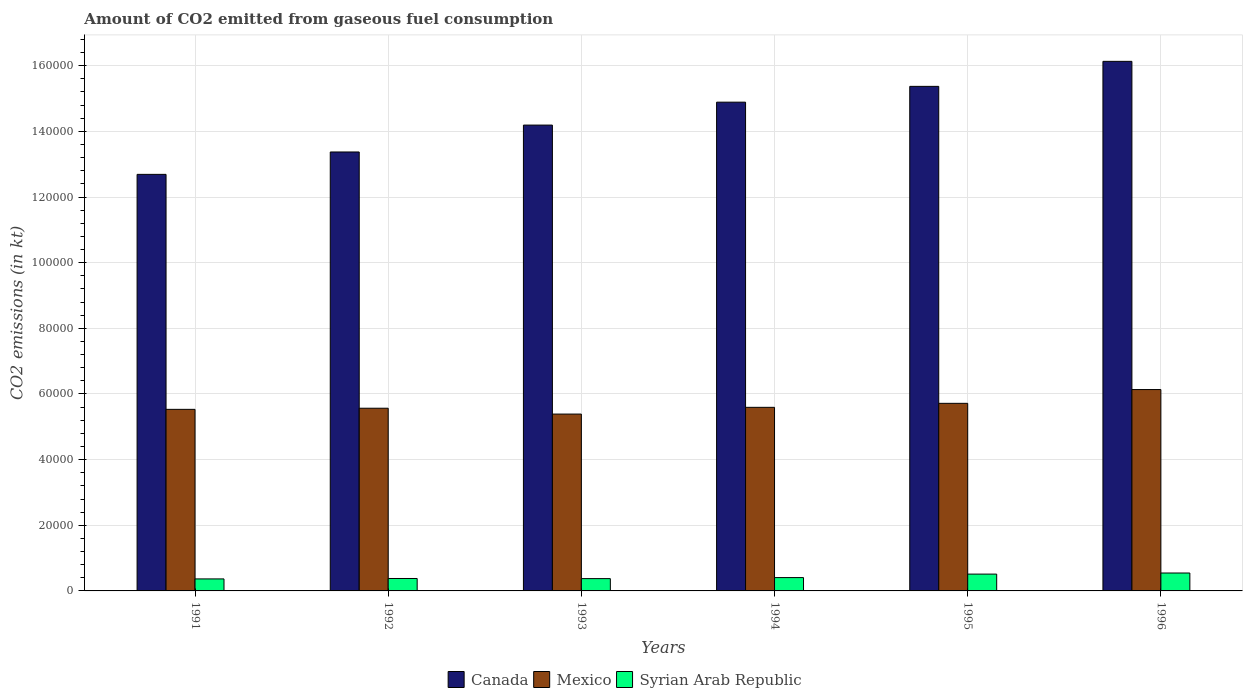Are the number of bars per tick equal to the number of legend labels?
Make the answer very short. Yes. Are the number of bars on each tick of the X-axis equal?
Keep it short and to the point. Yes. How many bars are there on the 5th tick from the right?
Your answer should be compact. 3. What is the label of the 3rd group of bars from the left?
Make the answer very short. 1993. What is the amount of CO2 emitted in Canada in 1994?
Offer a terse response. 1.49e+05. Across all years, what is the maximum amount of CO2 emitted in Syrian Arab Republic?
Offer a very short reply. 5456.5. Across all years, what is the minimum amount of CO2 emitted in Canada?
Keep it short and to the point. 1.27e+05. In which year was the amount of CO2 emitted in Canada maximum?
Keep it short and to the point. 1996. In which year was the amount of CO2 emitted in Mexico minimum?
Your response must be concise. 1993. What is the total amount of CO2 emitted in Mexico in the graph?
Offer a terse response. 3.39e+05. What is the difference between the amount of CO2 emitted in Canada in 1994 and that in 1995?
Keep it short and to the point. -4814.77. What is the difference between the amount of CO2 emitted in Canada in 1992 and the amount of CO2 emitted in Syrian Arab Republic in 1991?
Provide a succinct answer. 1.30e+05. What is the average amount of CO2 emitted in Syrian Arab Republic per year?
Keep it short and to the point. 4305.67. In the year 1995, what is the difference between the amount of CO2 emitted in Mexico and amount of CO2 emitted in Canada?
Your answer should be very brief. -9.66e+04. What is the ratio of the amount of CO2 emitted in Canada in 1995 to that in 1996?
Keep it short and to the point. 0.95. What is the difference between the highest and the second highest amount of CO2 emitted in Mexico?
Ensure brevity in your answer.  4198.72. What is the difference between the highest and the lowest amount of CO2 emitted in Syrian Arab Republic?
Offer a very short reply. 1796.83. What does the 3rd bar from the left in 1993 represents?
Give a very brief answer. Syrian Arab Republic. How many bars are there?
Keep it short and to the point. 18. Are all the bars in the graph horizontal?
Offer a very short reply. No. What is the difference between two consecutive major ticks on the Y-axis?
Offer a very short reply. 2.00e+04. Does the graph contain any zero values?
Provide a succinct answer. No. What is the title of the graph?
Your answer should be compact. Amount of CO2 emitted from gaseous fuel consumption. Does "South Africa" appear as one of the legend labels in the graph?
Your answer should be compact. No. What is the label or title of the Y-axis?
Ensure brevity in your answer.  CO2 emissions (in kt). What is the CO2 emissions (in kt) of Canada in 1991?
Make the answer very short. 1.27e+05. What is the CO2 emissions (in kt) in Mexico in 1991?
Offer a terse response. 5.53e+04. What is the CO2 emissions (in kt) in Syrian Arab Republic in 1991?
Keep it short and to the point. 3659.67. What is the CO2 emissions (in kt) in Canada in 1992?
Ensure brevity in your answer.  1.34e+05. What is the CO2 emissions (in kt) in Mexico in 1992?
Offer a very short reply. 5.57e+04. What is the CO2 emissions (in kt) in Syrian Arab Republic in 1992?
Offer a terse response. 3784.34. What is the CO2 emissions (in kt) in Canada in 1993?
Provide a short and direct response. 1.42e+05. What is the CO2 emissions (in kt) of Mexico in 1993?
Make the answer very short. 5.39e+04. What is the CO2 emissions (in kt) of Syrian Arab Republic in 1993?
Provide a short and direct response. 3747.67. What is the CO2 emissions (in kt) in Canada in 1994?
Offer a very short reply. 1.49e+05. What is the CO2 emissions (in kt) in Mexico in 1994?
Provide a short and direct response. 5.59e+04. What is the CO2 emissions (in kt) in Syrian Arab Republic in 1994?
Offer a very short reply. 4063.04. What is the CO2 emissions (in kt) in Canada in 1995?
Your answer should be very brief. 1.54e+05. What is the CO2 emissions (in kt) in Mexico in 1995?
Offer a very short reply. 5.71e+04. What is the CO2 emissions (in kt) of Syrian Arab Republic in 1995?
Your response must be concise. 5122.8. What is the CO2 emissions (in kt) in Canada in 1996?
Provide a succinct answer. 1.61e+05. What is the CO2 emissions (in kt) of Mexico in 1996?
Keep it short and to the point. 6.13e+04. What is the CO2 emissions (in kt) of Syrian Arab Republic in 1996?
Give a very brief answer. 5456.5. Across all years, what is the maximum CO2 emissions (in kt) of Canada?
Offer a terse response. 1.61e+05. Across all years, what is the maximum CO2 emissions (in kt) in Mexico?
Give a very brief answer. 6.13e+04. Across all years, what is the maximum CO2 emissions (in kt) of Syrian Arab Republic?
Keep it short and to the point. 5456.5. Across all years, what is the minimum CO2 emissions (in kt) in Canada?
Make the answer very short. 1.27e+05. Across all years, what is the minimum CO2 emissions (in kt) of Mexico?
Your answer should be compact. 5.39e+04. Across all years, what is the minimum CO2 emissions (in kt) of Syrian Arab Republic?
Provide a succinct answer. 3659.67. What is the total CO2 emissions (in kt) in Canada in the graph?
Your response must be concise. 8.66e+05. What is the total CO2 emissions (in kt) in Mexico in the graph?
Your response must be concise. 3.39e+05. What is the total CO2 emissions (in kt) in Syrian Arab Republic in the graph?
Keep it short and to the point. 2.58e+04. What is the difference between the CO2 emissions (in kt) of Canada in 1991 and that in 1992?
Your answer should be compact. -6820.62. What is the difference between the CO2 emissions (in kt) in Mexico in 1991 and that in 1992?
Offer a very short reply. -344.7. What is the difference between the CO2 emissions (in kt) in Syrian Arab Republic in 1991 and that in 1992?
Your answer should be very brief. -124.68. What is the difference between the CO2 emissions (in kt) in Canada in 1991 and that in 1993?
Offer a very short reply. -1.50e+04. What is the difference between the CO2 emissions (in kt) of Mexico in 1991 and that in 1993?
Keep it short and to the point. 1437.46. What is the difference between the CO2 emissions (in kt) of Syrian Arab Republic in 1991 and that in 1993?
Give a very brief answer. -88.01. What is the difference between the CO2 emissions (in kt) in Canada in 1991 and that in 1994?
Your answer should be compact. -2.20e+04. What is the difference between the CO2 emissions (in kt) in Mexico in 1991 and that in 1994?
Make the answer very short. -616.06. What is the difference between the CO2 emissions (in kt) of Syrian Arab Republic in 1991 and that in 1994?
Keep it short and to the point. -403.37. What is the difference between the CO2 emissions (in kt) of Canada in 1991 and that in 1995?
Offer a terse response. -2.68e+04. What is the difference between the CO2 emissions (in kt) of Mexico in 1991 and that in 1995?
Keep it short and to the point. -1833.5. What is the difference between the CO2 emissions (in kt) of Syrian Arab Republic in 1991 and that in 1995?
Provide a succinct answer. -1463.13. What is the difference between the CO2 emissions (in kt) in Canada in 1991 and that in 1996?
Keep it short and to the point. -3.44e+04. What is the difference between the CO2 emissions (in kt) of Mexico in 1991 and that in 1996?
Keep it short and to the point. -6032.22. What is the difference between the CO2 emissions (in kt) in Syrian Arab Republic in 1991 and that in 1996?
Offer a very short reply. -1796.83. What is the difference between the CO2 emissions (in kt) of Canada in 1992 and that in 1993?
Give a very brief answer. -8195.75. What is the difference between the CO2 emissions (in kt) of Mexico in 1992 and that in 1993?
Offer a terse response. 1782.16. What is the difference between the CO2 emissions (in kt) in Syrian Arab Republic in 1992 and that in 1993?
Make the answer very short. 36.67. What is the difference between the CO2 emissions (in kt) in Canada in 1992 and that in 1994?
Give a very brief answer. -1.52e+04. What is the difference between the CO2 emissions (in kt) of Mexico in 1992 and that in 1994?
Your answer should be compact. -271.36. What is the difference between the CO2 emissions (in kt) in Syrian Arab Republic in 1992 and that in 1994?
Make the answer very short. -278.69. What is the difference between the CO2 emissions (in kt) in Canada in 1992 and that in 1995?
Make the answer very short. -2.00e+04. What is the difference between the CO2 emissions (in kt) of Mexico in 1992 and that in 1995?
Make the answer very short. -1488.8. What is the difference between the CO2 emissions (in kt) of Syrian Arab Republic in 1992 and that in 1995?
Provide a short and direct response. -1338.45. What is the difference between the CO2 emissions (in kt) of Canada in 1992 and that in 1996?
Your answer should be compact. -2.76e+04. What is the difference between the CO2 emissions (in kt) in Mexico in 1992 and that in 1996?
Provide a succinct answer. -5687.52. What is the difference between the CO2 emissions (in kt) of Syrian Arab Republic in 1992 and that in 1996?
Your answer should be very brief. -1672.15. What is the difference between the CO2 emissions (in kt) of Canada in 1993 and that in 1994?
Give a very brief answer. -6978.3. What is the difference between the CO2 emissions (in kt) of Mexico in 1993 and that in 1994?
Your answer should be compact. -2053.52. What is the difference between the CO2 emissions (in kt) of Syrian Arab Republic in 1993 and that in 1994?
Keep it short and to the point. -315.36. What is the difference between the CO2 emissions (in kt) of Canada in 1993 and that in 1995?
Provide a short and direct response. -1.18e+04. What is the difference between the CO2 emissions (in kt) in Mexico in 1993 and that in 1995?
Ensure brevity in your answer.  -3270.96. What is the difference between the CO2 emissions (in kt) of Syrian Arab Republic in 1993 and that in 1995?
Make the answer very short. -1375.12. What is the difference between the CO2 emissions (in kt) of Canada in 1993 and that in 1996?
Your answer should be very brief. -1.94e+04. What is the difference between the CO2 emissions (in kt) of Mexico in 1993 and that in 1996?
Give a very brief answer. -7469.68. What is the difference between the CO2 emissions (in kt) in Syrian Arab Republic in 1993 and that in 1996?
Your answer should be very brief. -1708.82. What is the difference between the CO2 emissions (in kt) of Canada in 1994 and that in 1995?
Offer a terse response. -4814.77. What is the difference between the CO2 emissions (in kt) in Mexico in 1994 and that in 1995?
Make the answer very short. -1217.44. What is the difference between the CO2 emissions (in kt) of Syrian Arab Republic in 1994 and that in 1995?
Your answer should be very brief. -1059.76. What is the difference between the CO2 emissions (in kt) of Canada in 1994 and that in 1996?
Offer a terse response. -1.24e+04. What is the difference between the CO2 emissions (in kt) in Mexico in 1994 and that in 1996?
Your answer should be compact. -5416.16. What is the difference between the CO2 emissions (in kt) of Syrian Arab Republic in 1994 and that in 1996?
Your response must be concise. -1393.46. What is the difference between the CO2 emissions (in kt) in Canada in 1995 and that in 1996?
Ensure brevity in your answer.  -7620.03. What is the difference between the CO2 emissions (in kt) of Mexico in 1995 and that in 1996?
Keep it short and to the point. -4198.72. What is the difference between the CO2 emissions (in kt) of Syrian Arab Republic in 1995 and that in 1996?
Give a very brief answer. -333.7. What is the difference between the CO2 emissions (in kt) in Canada in 1991 and the CO2 emissions (in kt) in Mexico in 1992?
Keep it short and to the point. 7.12e+04. What is the difference between the CO2 emissions (in kt) in Canada in 1991 and the CO2 emissions (in kt) in Syrian Arab Republic in 1992?
Ensure brevity in your answer.  1.23e+05. What is the difference between the CO2 emissions (in kt) in Mexico in 1991 and the CO2 emissions (in kt) in Syrian Arab Republic in 1992?
Ensure brevity in your answer.  5.15e+04. What is the difference between the CO2 emissions (in kt) of Canada in 1991 and the CO2 emissions (in kt) of Mexico in 1993?
Provide a succinct answer. 7.30e+04. What is the difference between the CO2 emissions (in kt) in Canada in 1991 and the CO2 emissions (in kt) in Syrian Arab Republic in 1993?
Make the answer very short. 1.23e+05. What is the difference between the CO2 emissions (in kt) of Mexico in 1991 and the CO2 emissions (in kt) of Syrian Arab Republic in 1993?
Your response must be concise. 5.16e+04. What is the difference between the CO2 emissions (in kt) of Canada in 1991 and the CO2 emissions (in kt) of Mexico in 1994?
Give a very brief answer. 7.10e+04. What is the difference between the CO2 emissions (in kt) of Canada in 1991 and the CO2 emissions (in kt) of Syrian Arab Republic in 1994?
Your answer should be compact. 1.23e+05. What is the difference between the CO2 emissions (in kt) in Mexico in 1991 and the CO2 emissions (in kt) in Syrian Arab Republic in 1994?
Give a very brief answer. 5.12e+04. What is the difference between the CO2 emissions (in kt) in Canada in 1991 and the CO2 emissions (in kt) in Mexico in 1995?
Ensure brevity in your answer.  6.98e+04. What is the difference between the CO2 emissions (in kt) in Canada in 1991 and the CO2 emissions (in kt) in Syrian Arab Republic in 1995?
Offer a very short reply. 1.22e+05. What is the difference between the CO2 emissions (in kt) of Mexico in 1991 and the CO2 emissions (in kt) of Syrian Arab Republic in 1995?
Provide a succinct answer. 5.02e+04. What is the difference between the CO2 emissions (in kt) in Canada in 1991 and the CO2 emissions (in kt) in Mexico in 1996?
Your response must be concise. 6.56e+04. What is the difference between the CO2 emissions (in kt) in Canada in 1991 and the CO2 emissions (in kt) in Syrian Arab Republic in 1996?
Provide a short and direct response. 1.21e+05. What is the difference between the CO2 emissions (in kt) of Mexico in 1991 and the CO2 emissions (in kt) of Syrian Arab Republic in 1996?
Offer a terse response. 4.99e+04. What is the difference between the CO2 emissions (in kt) in Canada in 1992 and the CO2 emissions (in kt) in Mexico in 1993?
Offer a very short reply. 7.98e+04. What is the difference between the CO2 emissions (in kt) in Canada in 1992 and the CO2 emissions (in kt) in Syrian Arab Republic in 1993?
Offer a very short reply. 1.30e+05. What is the difference between the CO2 emissions (in kt) of Mexico in 1992 and the CO2 emissions (in kt) of Syrian Arab Republic in 1993?
Offer a terse response. 5.19e+04. What is the difference between the CO2 emissions (in kt) of Canada in 1992 and the CO2 emissions (in kt) of Mexico in 1994?
Ensure brevity in your answer.  7.78e+04. What is the difference between the CO2 emissions (in kt) of Canada in 1992 and the CO2 emissions (in kt) of Syrian Arab Republic in 1994?
Your response must be concise. 1.30e+05. What is the difference between the CO2 emissions (in kt) of Mexico in 1992 and the CO2 emissions (in kt) of Syrian Arab Republic in 1994?
Ensure brevity in your answer.  5.16e+04. What is the difference between the CO2 emissions (in kt) of Canada in 1992 and the CO2 emissions (in kt) of Mexico in 1995?
Your response must be concise. 7.66e+04. What is the difference between the CO2 emissions (in kt) of Canada in 1992 and the CO2 emissions (in kt) of Syrian Arab Republic in 1995?
Your response must be concise. 1.29e+05. What is the difference between the CO2 emissions (in kt) in Mexico in 1992 and the CO2 emissions (in kt) in Syrian Arab Republic in 1995?
Your answer should be compact. 5.05e+04. What is the difference between the CO2 emissions (in kt) in Canada in 1992 and the CO2 emissions (in kt) in Mexico in 1996?
Offer a very short reply. 7.24e+04. What is the difference between the CO2 emissions (in kt) in Canada in 1992 and the CO2 emissions (in kt) in Syrian Arab Republic in 1996?
Give a very brief answer. 1.28e+05. What is the difference between the CO2 emissions (in kt) of Mexico in 1992 and the CO2 emissions (in kt) of Syrian Arab Republic in 1996?
Provide a succinct answer. 5.02e+04. What is the difference between the CO2 emissions (in kt) in Canada in 1993 and the CO2 emissions (in kt) in Mexico in 1994?
Offer a very short reply. 8.60e+04. What is the difference between the CO2 emissions (in kt) in Canada in 1993 and the CO2 emissions (in kt) in Syrian Arab Republic in 1994?
Give a very brief answer. 1.38e+05. What is the difference between the CO2 emissions (in kt) in Mexico in 1993 and the CO2 emissions (in kt) in Syrian Arab Republic in 1994?
Provide a succinct answer. 4.98e+04. What is the difference between the CO2 emissions (in kt) of Canada in 1993 and the CO2 emissions (in kt) of Mexico in 1995?
Your answer should be compact. 8.48e+04. What is the difference between the CO2 emissions (in kt) of Canada in 1993 and the CO2 emissions (in kt) of Syrian Arab Republic in 1995?
Offer a very short reply. 1.37e+05. What is the difference between the CO2 emissions (in kt) in Mexico in 1993 and the CO2 emissions (in kt) in Syrian Arab Republic in 1995?
Your answer should be very brief. 4.88e+04. What is the difference between the CO2 emissions (in kt) of Canada in 1993 and the CO2 emissions (in kt) of Mexico in 1996?
Your answer should be very brief. 8.06e+04. What is the difference between the CO2 emissions (in kt) of Canada in 1993 and the CO2 emissions (in kt) of Syrian Arab Republic in 1996?
Offer a terse response. 1.36e+05. What is the difference between the CO2 emissions (in kt) in Mexico in 1993 and the CO2 emissions (in kt) in Syrian Arab Republic in 1996?
Offer a very short reply. 4.84e+04. What is the difference between the CO2 emissions (in kt) of Canada in 1994 and the CO2 emissions (in kt) of Mexico in 1995?
Your answer should be very brief. 9.17e+04. What is the difference between the CO2 emissions (in kt) of Canada in 1994 and the CO2 emissions (in kt) of Syrian Arab Republic in 1995?
Your answer should be compact. 1.44e+05. What is the difference between the CO2 emissions (in kt) of Mexico in 1994 and the CO2 emissions (in kt) of Syrian Arab Republic in 1995?
Keep it short and to the point. 5.08e+04. What is the difference between the CO2 emissions (in kt) of Canada in 1994 and the CO2 emissions (in kt) of Mexico in 1996?
Give a very brief answer. 8.75e+04. What is the difference between the CO2 emissions (in kt) in Canada in 1994 and the CO2 emissions (in kt) in Syrian Arab Republic in 1996?
Your answer should be very brief. 1.43e+05. What is the difference between the CO2 emissions (in kt) in Mexico in 1994 and the CO2 emissions (in kt) in Syrian Arab Republic in 1996?
Make the answer very short. 5.05e+04. What is the difference between the CO2 emissions (in kt) of Canada in 1995 and the CO2 emissions (in kt) of Mexico in 1996?
Provide a succinct answer. 9.24e+04. What is the difference between the CO2 emissions (in kt) of Canada in 1995 and the CO2 emissions (in kt) of Syrian Arab Republic in 1996?
Offer a very short reply. 1.48e+05. What is the difference between the CO2 emissions (in kt) of Mexico in 1995 and the CO2 emissions (in kt) of Syrian Arab Republic in 1996?
Make the answer very short. 5.17e+04. What is the average CO2 emissions (in kt) in Canada per year?
Your answer should be very brief. 1.44e+05. What is the average CO2 emissions (in kt) of Mexico per year?
Your answer should be compact. 5.65e+04. What is the average CO2 emissions (in kt) in Syrian Arab Republic per year?
Offer a very short reply. 4305.67. In the year 1991, what is the difference between the CO2 emissions (in kt) in Canada and CO2 emissions (in kt) in Mexico?
Provide a short and direct response. 7.16e+04. In the year 1991, what is the difference between the CO2 emissions (in kt) in Canada and CO2 emissions (in kt) in Syrian Arab Republic?
Provide a short and direct response. 1.23e+05. In the year 1991, what is the difference between the CO2 emissions (in kt) in Mexico and CO2 emissions (in kt) in Syrian Arab Republic?
Make the answer very short. 5.17e+04. In the year 1992, what is the difference between the CO2 emissions (in kt) in Canada and CO2 emissions (in kt) in Mexico?
Make the answer very short. 7.81e+04. In the year 1992, what is the difference between the CO2 emissions (in kt) of Canada and CO2 emissions (in kt) of Syrian Arab Republic?
Give a very brief answer. 1.30e+05. In the year 1992, what is the difference between the CO2 emissions (in kt) in Mexico and CO2 emissions (in kt) in Syrian Arab Republic?
Offer a very short reply. 5.19e+04. In the year 1993, what is the difference between the CO2 emissions (in kt) of Canada and CO2 emissions (in kt) of Mexico?
Your answer should be very brief. 8.80e+04. In the year 1993, what is the difference between the CO2 emissions (in kt) of Canada and CO2 emissions (in kt) of Syrian Arab Republic?
Offer a terse response. 1.38e+05. In the year 1993, what is the difference between the CO2 emissions (in kt) of Mexico and CO2 emissions (in kt) of Syrian Arab Republic?
Make the answer very short. 5.01e+04. In the year 1994, what is the difference between the CO2 emissions (in kt) in Canada and CO2 emissions (in kt) in Mexico?
Offer a terse response. 9.30e+04. In the year 1994, what is the difference between the CO2 emissions (in kt) of Canada and CO2 emissions (in kt) of Syrian Arab Republic?
Offer a very short reply. 1.45e+05. In the year 1994, what is the difference between the CO2 emissions (in kt) in Mexico and CO2 emissions (in kt) in Syrian Arab Republic?
Ensure brevity in your answer.  5.19e+04. In the year 1995, what is the difference between the CO2 emissions (in kt) of Canada and CO2 emissions (in kt) of Mexico?
Offer a very short reply. 9.66e+04. In the year 1995, what is the difference between the CO2 emissions (in kt) of Canada and CO2 emissions (in kt) of Syrian Arab Republic?
Make the answer very short. 1.49e+05. In the year 1995, what is the difference between the CO2 emissions (in kt) of Mexico and CO2 emissions (in kt) of Syrian Arab Republic?
Ensure brevity in your answer.  5.20e+04. In the year 1996, what is the difference between the CO2 emissions (in kt) of Canada and CO2 emissions (in kt) of Mexico?
Your response must be concise. 1.00e+05. In the year 1996, what is the difference between the CO2 emissions (in kt) of Canada and CO2 emissions (in kt) of Syrian Arab Republic?
Your answer should be very brief. 1.56e+05. In the year 1996, what is the difference between the CO2 emissions (in kt) of Mexico and CO2 emissions (in kt) of Syrian Arab Republic?
Your answer should be compact. 5.59e+04. What is the ratio of the CO2 emissions (in kt) of Canada in 1991 to that in 1992?
Ensure brevity in your answer.  0.95. What is the ratio of the CO2 emissions (in kt) in Mexico in 1991 to that in 1992?
Keep it short and to the point. 0.99. What is the ratio of the CO2 emissions (in kt) in Syrian Arab Republic in 1991 to that in 1992?
Give a very brief answer. 0.97. What is the ratio of the CO2 emissions (in kt) of Canada in 1991 to that in 1993?
Ensure brevity in your answer.  0.89. What is the ratio of the CO2 emissions (in kt) in Mexico in 1991 to that in 1993?
Offer a very short reply. 1.03. What is the ratio of the CO2 emissions (in kt) in Syrian Arab Republic in 1991 to that in 1993?
Ensure brevity in your answer.  0.98. What is the ratio of the CO2 emissions (in kt) of Canada in 1991 to that in 1994?
Offer a very short reply. 0.85. What is the ratio of the CO2 emissions (in kt) of Syrian Arab Republic in 1991 to that in 1994?
Make the answer very short. 0.9. What is the ratio of the CO2 emissions (in kt) of Canada in 1991 to that in 1995?
Offer a terse response. 0.83. What is the ratio of the CO2 emissions (in kt) in Mexico in 1991 to that in 1995?
Your answer should be compact. 0.97. What is the ratio of the CO2 emissions (in kt) of Syrian Arab Republic in 1991 to that in 1995?
Ensure brevity in your answer.  0.71. What is the ratio of the CO2 emissions (in kt) in Canada in 1991 to that in 1996?
Give a very brief answer. 0.79. What is the ratio of the CO2 emissions (in kt) in Mexico in 1991 to that in 1996?
Ensure brevity in your answer.  0.9. What is the ratio of the CO2 emissions (in kt) of Syrian Arab Republic in 1991 to that in 1996?
Your answer should be very brief. 0.67. What is the ratio of the CO2 emissions (in kt) of Canada in 1992 to that in 1993?
Your answer should be very brief. 0.94. What is the ratio of the CO2 emissions (in kt) of Mexico in 1992 to that in 1993?
Ensure brevity in your answer.  1.03. What is the ratio of the CO2 emissions (in kt) of Syrian Arab Republic in 1992 to that in 1993?
Make the answer very short. 1.01. What is the ratio of the CO2 emissions (in kt) in Canada in 1992 to that in 1994?
Your response must be concise. 0.9. What is the ratio of the CO2 emissions (in kt) of Mexico in 1992 to that in 1994?
Provide a short and direct response. 1. What is the ratio of the CO2 emissions (in kt) in Syrian Arab Republic in 1992 to that in 1994?
Your answer should be compact. 0.93. What is the ratio of the CO2 emissions (in kt) of Canada in 1992 to that in 1995?
Give a very brief answer. 0.87. What is the ratio of the CO2 emissions (in kt) of Mexico in 1992 to that in 1995?
Your response must be concise. 0.97. What is the ratio of the CO2 emissions (in kt) of Syrian Arab Republic in 1992 to that in 1995?
Your response must be concise. 0.74. What is the ratio of the CO2 emissions (in kt) in Canada in 1992 to that in 1996?
Keep it short and to the point. 0.83. What is the ratio of the CO2 emissions (in kt) of Mexico in 1992 to that in 1996?
Ensure brevity in your answer.  0.91. What is the ratio of the CO2 emissions (in kt) in Syrian Arab Republic in 1992 to that in 1996?
Provide a short and direct response. 0.69. What is the ratio of the CO2 emissions (in kt) in Canada in 1993 to that in 1994?
Offer a terse response. 0.95. What is the ratio of the CO2 emissions (in kt) of Mexico in 1993 to that in 1994?
Ensure brevity in your answer.  0.96. What is the ratio of the CO2 emissions (in kt) of Syrian Arab Republic in 1993 to that in 1994?
Your answer should be compact. 0.92. What is the ratio of the CO2 emissions (in kt) in Canada in 1993 to that in 1995?
Ensure brevity in your answer.  0.92. What is the ratio of the CO2 emissions (in kt) of Mexico in 1993 to that in 1995?
Your response must be concise. 0.94. What is the ratio of the CO2 emissions (in kt) of Syrian Arab Republic in 1993 to that in 1995?
Offer a terse response. 0.73. What is the ratio of the CO2 emissions (in kt) of Canada in 1993 to that in 1996?
Give a very brief answer. 0.88. What is the ratio of the CO2 emissions (in kt) of Mexico in 1993 to that in 1996?
Keep it short and to the point. 0.88. What is the ratio of the CO2 emissions (in kt) in Syrian Arab Republic in 1993 to that in 1996?
Your response must be concise. 0.69. What is the ratio of the CO2 emissions (in kt) of Canada in 1994 to that in 1995?
Keep it short and to the point. 0.97. What is the ratio of the CO2 emissions (in kt) of Mexico in 1994 to that in 1995?
Keep it short and to the point. 0.98. What is the ratio of the CO2 emissions (in kt) of Syrian Arab Republic in 1994 to that in 1995?
Your answer should be compact. 0.79. What is the ratio of the CO2 emissions (in kt) in Canada in 1994 to that in 1996?
Ensure brevity in your answer.  0.92. What is the ratio of the CO2 emissions (in kt) in Mexico in 1994 to that in 1996?
Provide a succinct answer. 0.91. What is the ratio of the CO2 emissions (in kt) of Syrian Arab Republic in 1994 to that in 1996?
Provide a succinct answer. 0.74. What is the ratio of the CO2 emissions (in kt) of Canada in 1995 to that in 1996?
Your answer should be compact. 0.95. What is the ratio of the CO2 emissions (in kt) of Mexico in 1995 to that in 1996?
Make the answer very short. 0.93. What is the ratio of the CO2 emissions (in kt) in Syrian Arab Republic in 1995 to that in 1996?
Your response must be concise. 0.94. What is the difference between the highest and the second highest CO2 emissions (in kt) in Canada?
Your answer should be very brief. 7620.03. What is the difference between the highest and the second highest CO2 emissions (in kt) in Mexico?
Make the answer very short. 4198.72. What is the difference between the highest and the second highest CO2 emissions (in kt) of Syrian Arab Republic?
Your response must be concise. 333.7. What is the difference between the highest and the lowest CO2 emissions (in kt) of Canada?
Provide a short and direct response. 3.44e+04. What is the difference between the highest and the lowest CO2 emissions (in kt) in Mexico?
Your response must be concise. 7469.68. What is the difference between the highest and the lowest CO2 emissions (in kt) in Syrian Arab Republic?
Keep it short and to the point. 1796.83. 